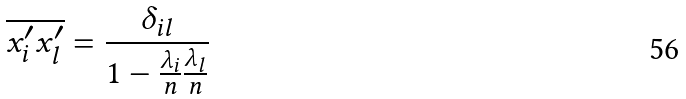<formula> <loc_0><loc_0><loc_500><loc_500>\overline { x ^ { \prime } _ { i } x ^ { \prime } _ { l } } = \frac { \delta _ { i l } } { 1 - \frac { \lambda _ { i } } { n } \frac { \lambda _ { l } } { n } }</formula> 